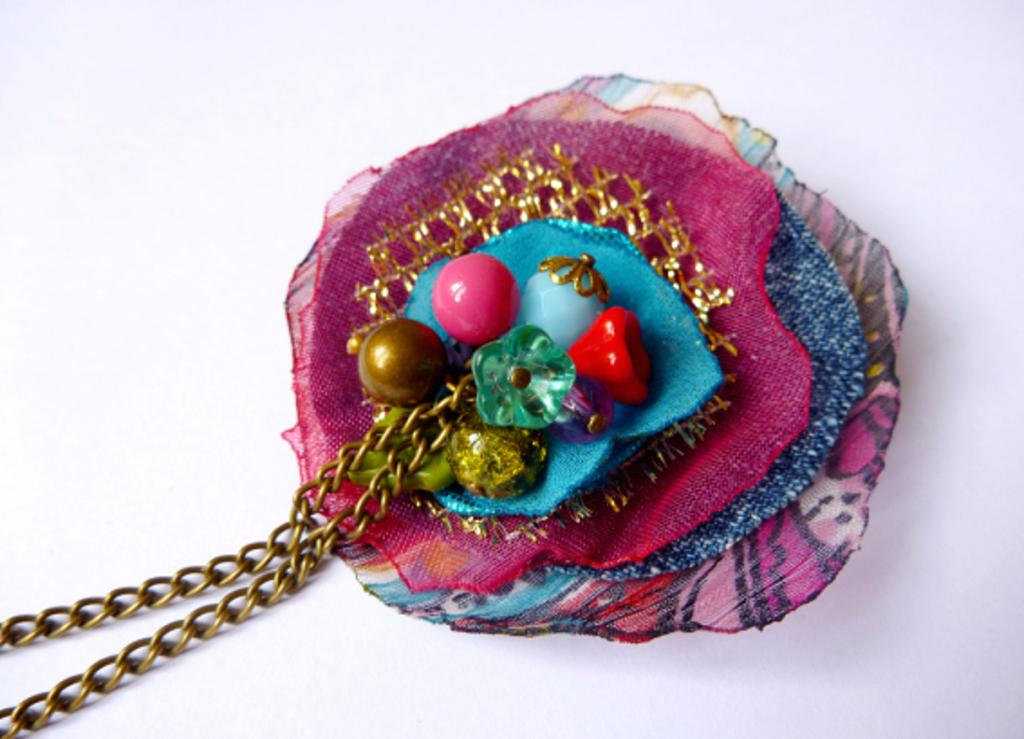What is the main object in the image? There is a locket with chains in the image. What color is the background of the image? The background of the image is white. What type of drink is being served at the cemetery in the image? There is no cemetery or drink present in the image; it only features a locket with chains against a white background. 